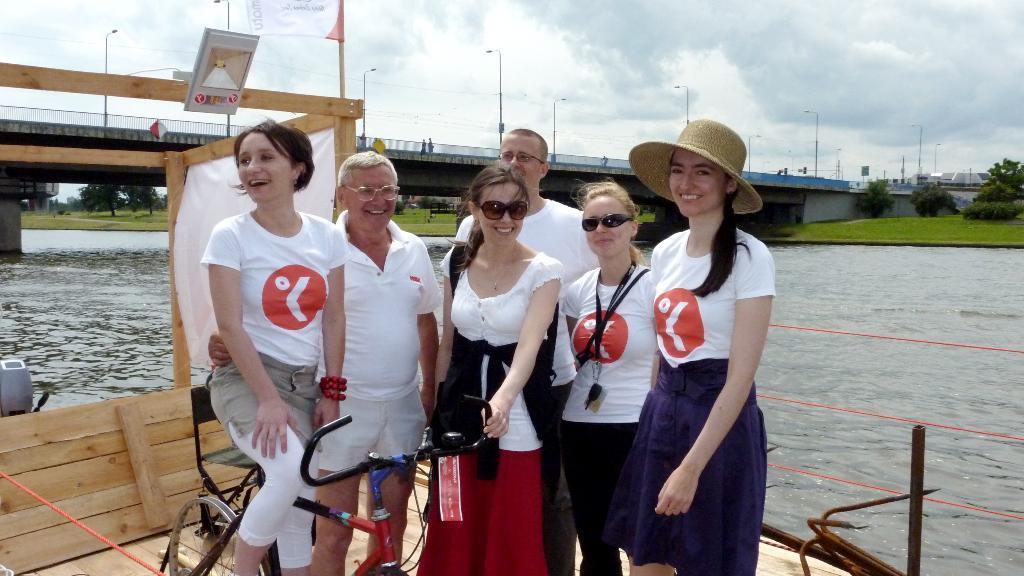How would you summarize this image in a sentence or two? As we can see in the image there is a sky, bridge, water, trees and few people standing over here. 